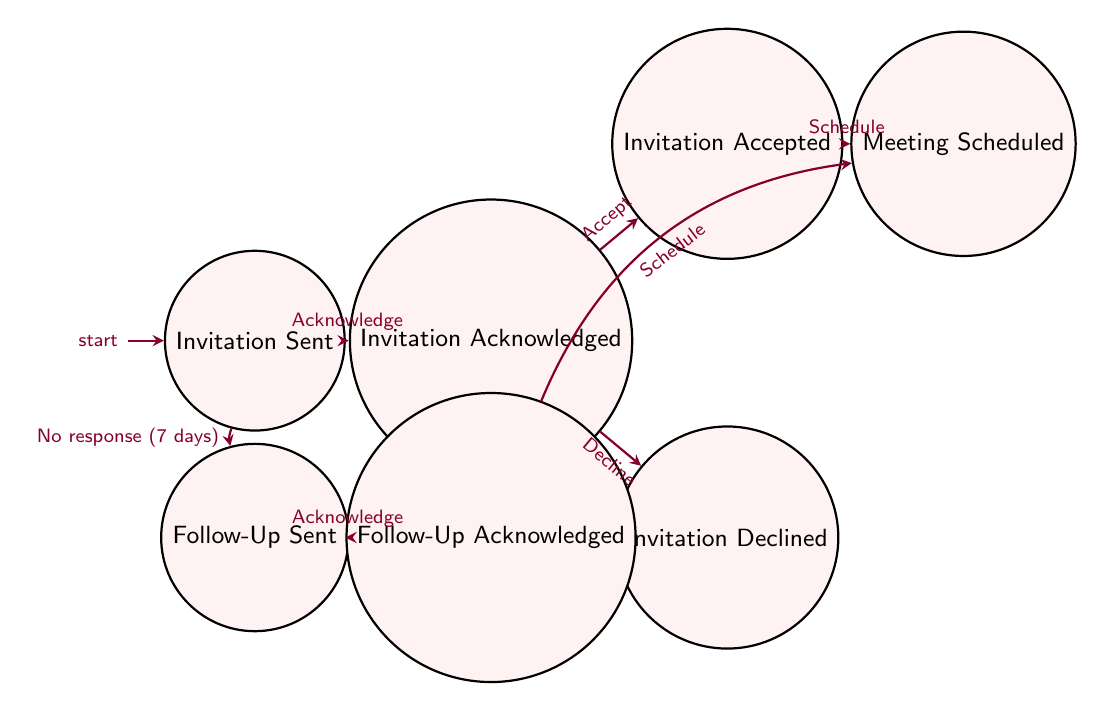What is the initial state of the diagram? The initial state is "Invitation Sent", which is the first node in the diagram.
Answer: Invitation Sent How many states are in the diagram? The diagram contains a total of 7 states, as listed in the data model.
Answer: 7 What transition occurs after the invitation is acknowledged if the celebrity accepts it? The next state after "Invitation Acknowledged" when the invitation is accepted is "Invitation Accepted."
Answer: Invitation Accepted What state follows "Follow-Up Sent" if the follow-up is acknowledged? The state that follows "Follow-Up Sent" when the follow-up is acknowledged is "Follow-Up Acknowledged."
Answer: Follow-Up Acknowledged Which state is reached when an invitation is declined? The state that is reached when an invitation is declined is "Invitation Declined."
Answer: Invitation Declined What is the condition required to transition from "Invitation Sent" to "Follow-Up Sent"? The condition to transition from "Invitation Sent" to "Follow-Up Sent" is that there is "No response within 7 days."
Answer: No response (7 days) What states can lead directly to the "Meeting Scheduled" state? There are two states that lead directly to "Meeting Scheduled": "Invitation Accepted" and "Follow-Up Acknowledged."
Answer: Invitation Accepted, Follow-Up Acknowledged How many transitions originate from "Invitation Acknowledged"? There are two transitions that originate from "Invitation Acknowledged": "Accept Invitation" and "Decline Invitation."
Answer: 2 What is the final state if the follow-up is acknowledged? If the follow-up is acknowledged, the final state that can be reached is "Meeting Scheduled."
Answer: Meeting Scheduled Which node receives an acknowledgment from the corresponding follow-up message? The node that receives an acknowledgment from the corresponding follow-up message is "Follow-Up Acknowledged."
Answer: Follow-Up Acknowledged 